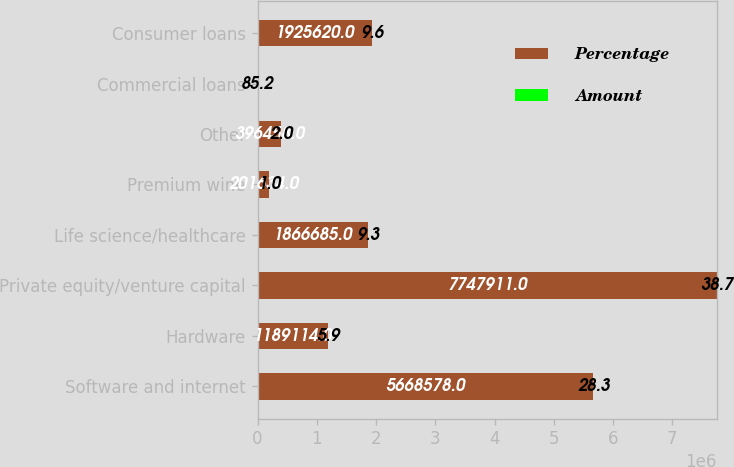Convert chart. <chart><loc_0><loc_0><loc_500><loc_500><stacked_bar_chart><ecel><fcel>Software and internet<fcel>Hardware<fcel>Private equity/venture capital<fcel>Life science/healthcare<fcel>Premium wine<fcel>Other<fcel>Commercial loans<fcel>Consumer loans<nl><fcel>Percentage<fcel>5.66858e+06<fcel>1.18911e+06<fcel>7.74791e+06<fcel>1.86668e+06<fcel>201634<fcel>396458<fcel>85.2<fcel>1.92562e+06<nl><fcel>Amount<fcel>28.3<fcel>5.9<fcel>38.7<fcel>9.3<fcel>1<fcel>2<fcel>85.2<fcel>9.6<nl></chart> 